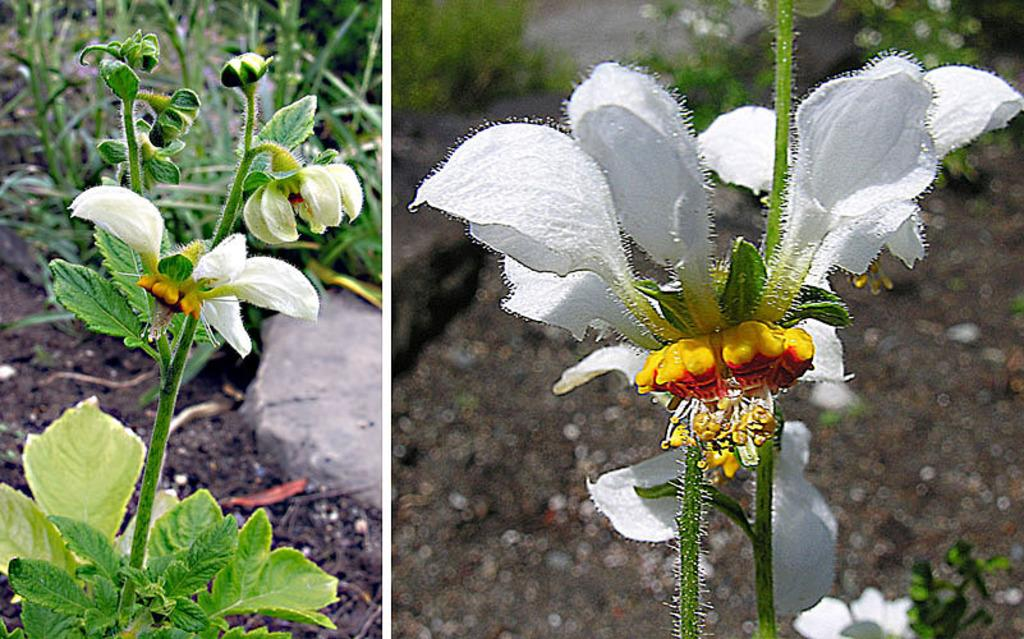What type of living organisms can be seen in the image? Plants can be seen in the image. What non-living object is present in the image? There is a stone in the image. Right Image: What type of flower can be seen in the image? There is a white flower in the image. What type of selection process is being used to choose the best leaf in the image? There is no selection process or leaves present in the images; they only show plants and a white flower. 